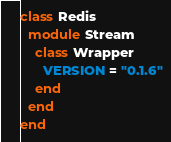Convert code to text. <code><loc_0><loc_0><loc_500><loc_500><_Ruby_>class Redis
  module Stream
    class Wrapper
      VERSION = "0.1.6"
    end
  end
end
</code> 